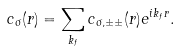Convert formula to latex. <formula><loc_0><loc_0><loc_500><loc_500>c _ { \sigma } ( { r } ) = \sum _ { k _ { f } } c _ { \sigma , \pm \pm } ( { r } ) e ^ { i { k } _ { f } { r } } .</formula> 